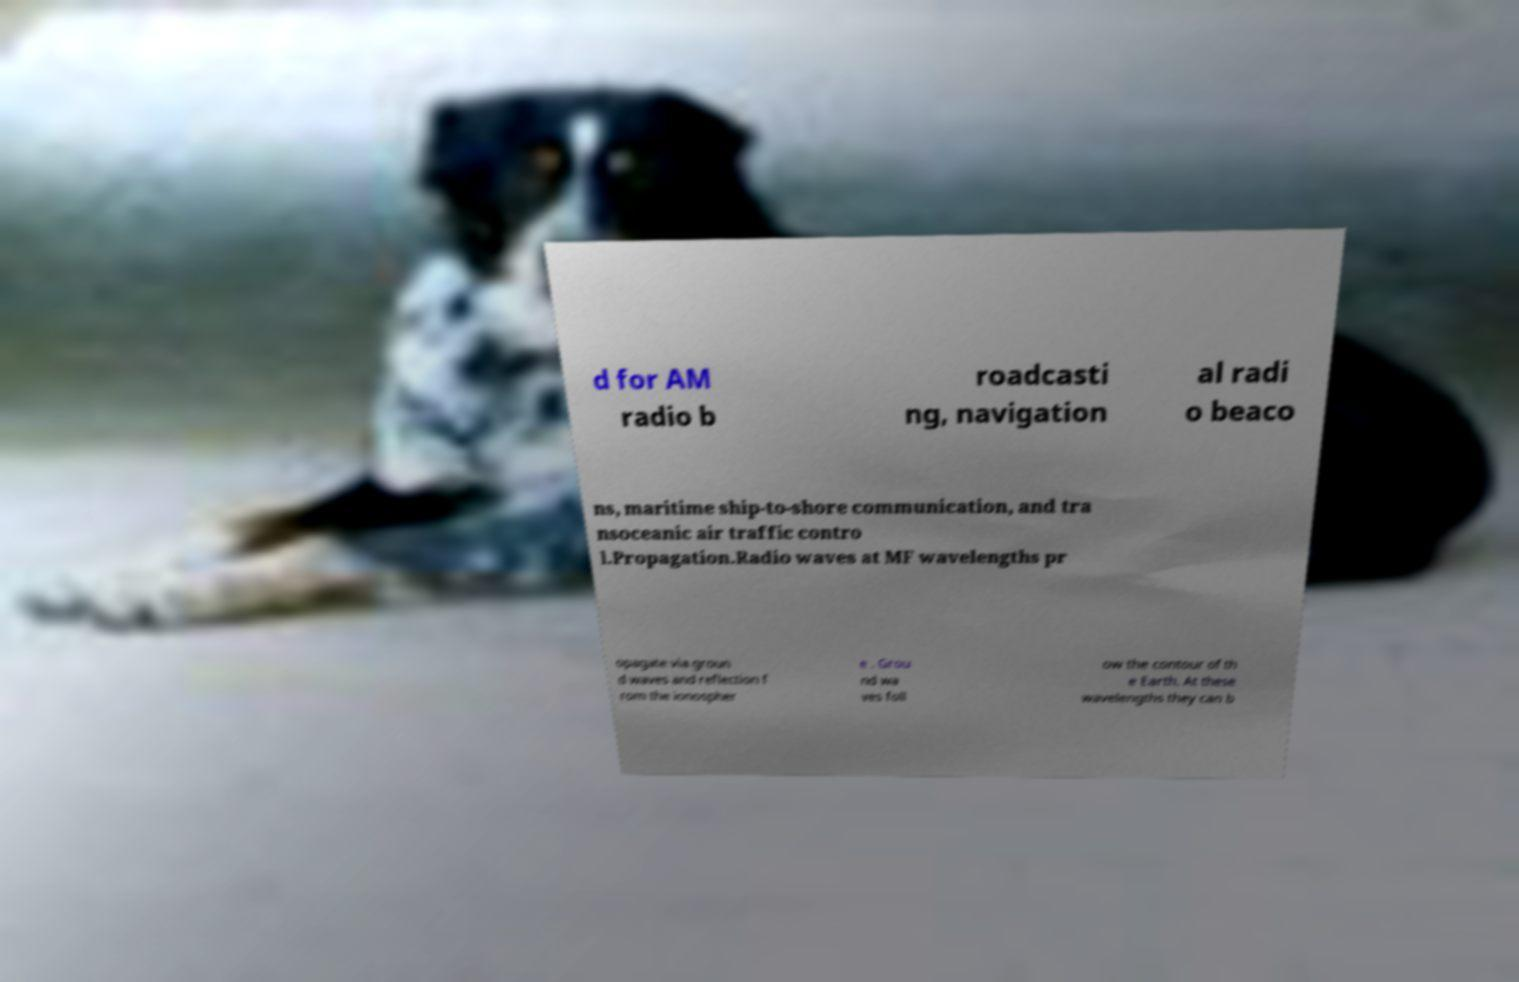Please identify and transcribe the text found in this image. d for AM radio b roadcasti ng, navigation al radi o beaco ns, maritime ship-to-shore communication, and tra nsoceanic air traffic contro l.Propagation.Radio waves at MF wavelengths pr opagate via groun d waves and reflection f rom the ionospher e . Grou nd wa ves foll ow the contour of th e Earth. At these wavelengths they can b 